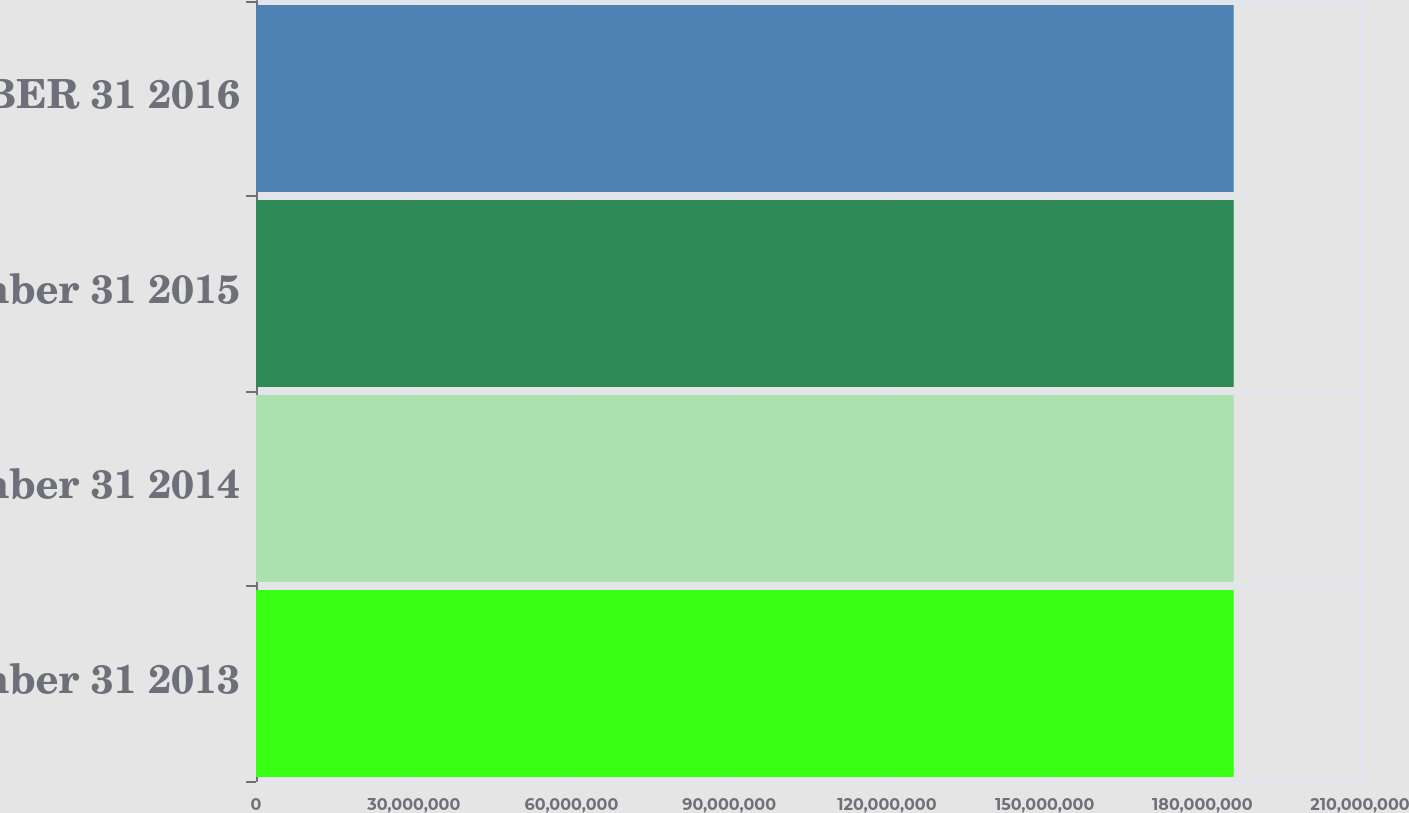<chart> <loc_0><loc_0><loc_500><loc_500><bar_chart><fcel>December 31 2013<fcel>December 31 2014<fcel>December 31 2015<fcel>DECEMBER 31 2016<nl><fcel>1.85984e+08<fcel>1.85984e+08<fcel>1.85984e+08<fcel>1.85984e+08<nl></chart> 